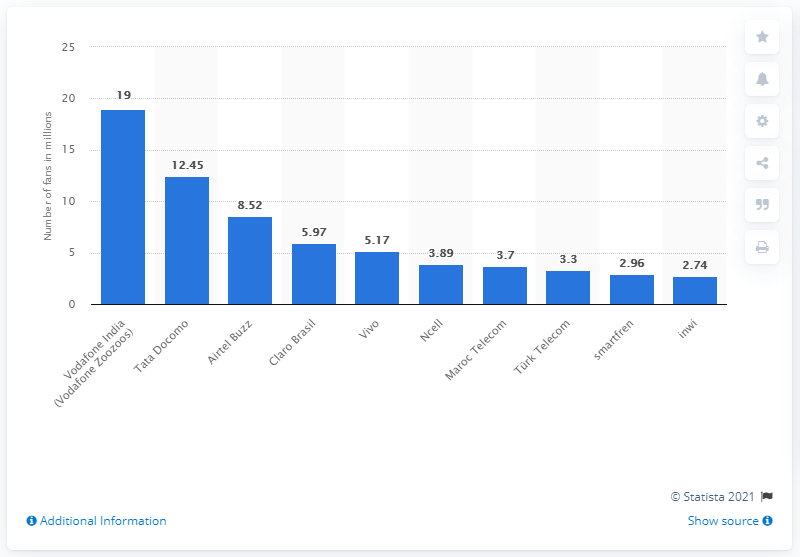Point out several critical features in this image. As of June 2020, Zoozoos had 19 fans on Facebook. 